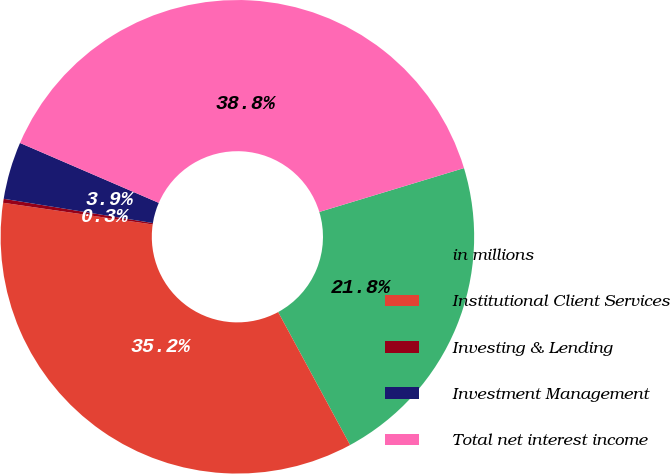Convert chart. <chart><loc_0><loc_0><loc_500><loc_500><pie_chart><fcel>in millions<fcel>Institutional Client Services<fcel>Investing & Lending<fcel>Investment Management<fcel>Total net interest income<nl><fcel>21.79%<fcel>35.19%<fcel>0.27%<fcel>3.92%<fcel>38.83%<nl></chart> 